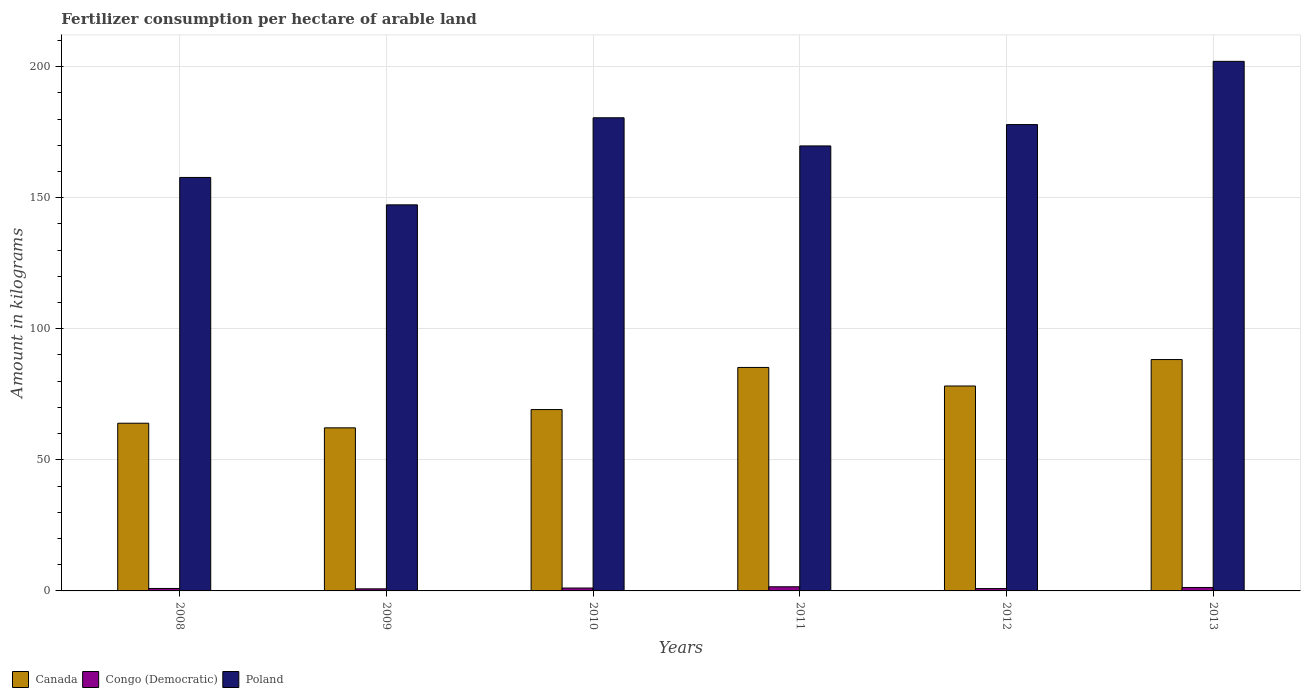Are the number of bars on each tick of the X-axis equal?
Offer a very short reply. Yes. How many bars are there on the 3rd tick from the left?
Ensure brevity in your answer.  3. How many bars are there on the 6th tick from the right?
Ensure brevity in your answer.  3. What is the amount of fertilizer consumption in Congo (Democratic) in 2012?
Give a very brief answer. 0.89. Across all years, what is the maximum amount of fertilizer consumption in Congo (Democratic)?
Provide a succinct answer. 1.58. Across all years, what is the minimum amount of fertilizer consumption in Canada?
Make the answer very short. 62.21. In which year was the amount of fertilizer consumption in Congo (Democratic) maximum?
Provide a short and direct response. 2011. In which year was the amount of fertilizer consumption in Canada minimum?
Provide a succinct answer. 2009. What is the total amount of fertilizer consumption in Poland in the graph?
Make the answer very short. 1035.09. What is the difference between the amount of fertilizer consumption in Canada in 2008 and that in 2009?
Offer a very short reply. 1.76. What is the difference between the amount of fertilizer consumption in Poland in 2010 and the amount of fertilizer consumption in Congo (Democratic) in 2009?
Provide a short and direct response. 179.68. What is the average amount of fertilizer consumption in Poland per year?
Your answer should be compact. 172.52. In the year 2009, what is the difference between the amount of fertilizer consumption in Canada and amount of fertilizer consumption in Poland?
Keep it short and to the point. -85.06. What is the ratio of the amount of fertilizer consumption in Poland in 2010 to that in 2012?
Keep it short and to the point. 1.01. Is the amount of fertilizer consumption in Congo (Democratic) in 2008 less than that in 2013?
Make the answer very short. Yes. Is the difference between the amount of fertilizer consumption in Canada in 2012 and 2013 greater than the difference between the amount of fertilizer consumption in Poland in 2012 and 2013?
Your answer should be very brief. Yes. What is the difference between the highest and the second highest amount of fertilizer consumption in Poland?
Offer a very short reply. 21.52. What is the difference between the highest and the lowest amount of fertilizer consumption in Canada?
Offer a terse response. 26.04. Is the sum of the amount of fertilizer consumption in Poland in 2009 and 2013 greater than the maximum amount of fertilizer consumption in Canada across all years?
Offer a very short reply. Yes. What does the 2nd bar from the left in 2013 represents?
Make the answer very short. Congo (Democratic). Are all the bars in the graph horizontal?
Your answer should be very brief. No. What is the difference between two consecutive major ticks on the Y-axis?
Give a very brief answer. 50. Are the values on the major ticks of Y-axis written in scientific E-notation?
Your response must be concise. No. Does the graph contain grids?
Offer a very short reply. Yes. How many legend labels are there?
Your answer should be very brief. 3. What is the title of the graph?
Your answer should be compact. Fertilizer consumption per hectare of arable land. What is the label or title of the X-axis?
Your response must be concise. Years. What is the label or title of the Y-axis?
Your answer should be compact. Amount in kilograms. What is the Amount in kilograms in Canada in 2008?
Ensure brevity in your answer.  63.96. What is the Amount in kilograms of Congo (Democratic) in 2008?
Offer a very short reply. 0.94. What is the Amount in kilograms in Poland in 2008?
Offer a terse response. 157.72. What is the Amount in kilograms of Canada in 2009?
Give a very brief answer. 62.21. What is the Amount in kilograms of Congo (Democratic) in 2009?
Give a very brief answer. 0.8. What is the Amount in kilograms of Poland in 2009?
Your answer should be compact. 147.27. What is the Amount in kilograms in Canada in 2010?
Keep it short and to the point. 69.18. What is the Amount in kilograms of Congo (Democratic) in 2010?
Your answer should be compact. 1.1. What is the Amount in kilograms of Poland in 2010?
Your answer should be very brief. 180.48. What is the Amount in kilograms in Canada in 2011?
Provide a short and direct response. 85.24. What is the Amount in kilograms of Congo (Democratic) in 2011?
Offer a terse response. 1.58. What is the Amount in kilograms of Poland in 2011?
Offer a terse response. 169.74. What is the Amount in kilograms in Canada in 2012?
Your answer should be very brief. 78.17. What is the Amount in kilograms in Congo (Democratic) in 2012?
Make the answer very short. 0.89. What is the Amount in kilograms in Poland in 2012?
Your response must be concise. 177.89. What is the Amount in kilograms of Canada in 2013?
Keep it short and to the point. 88.25. What is the Amount in kilograms in Congo (Democratic) in 2013?
Keep it short and to the point. 1.31. What is the Amount in kilograms in Poland in 2013?
Offer a terse response. 202. Across all years, what is the maximum Amount in kilograms in Canada?
Offer a terse response. 88.25. Across all years, what is the maximum Amount in kilograms in Congo (Democratic)?
Provide a succinct answer. 1.58. Across all years, what is the maximum Amount in kilograms of Poland?
Make the answer very short. 202. Across all years, what is the minimum Amount in kilograms of Canada?
Your response must be concise. 62.21. Across all years, what is the minimum Amount in kilograms in Congo (Democratic)?
Give a very brief answer. 0.8. Across all years, what is the minimum Amount in kilograms in Poland?
Offer a terse response. 147.27. What is the total Amount in kilograms of Canada in the graph?
Your answer should be compact. 447.01. What is the total Amount in kilograms of Congo (Democratic) in the graph?
Ensure brevity in your answer.  6.63. What is the total Amount in kilograms of Poland in the graph?
Offer a terse response. 1035.09. What is the difference between the Amount in kilograms of Canada in 2008 and that in 2009?
Your answer should be compact. 1.76. What is the difference between the Amount in kilograms of Congo (Democratic) in 2008 and that in 2009?
Your answer should be compact. 0.14. What is the difference between the Amount in kilograms in Poland in 2008 and that in 2009?
Provide a succinct answer. 10.45. What is the difference between the Amount in kilograms in Canada in 2008 and that in 2010?
Give a very brief answer. -5.21. What is the difference between the Amount in kilograms of Congo (Democratic) in 2008 and that in 2010?
Give a very brief answer. -0.16. What is the difference between the Amount in kilograms in Poland in 2008 and that in 2010?
Keep it short and to the point. -22.76. What is the difference between the Amount in kilograms in Canada in 2008 and that in 2011?
Offer a terse response. -21.28. What is the difference between the Amount in kilograms of Congo (Democratic) in 2008 and that in 2011?
Your response must be concise. -0.64. What is the difference between the Amount in kilograms in Poland in 2008 and that in 2011?
Give a very brief answer. -12.02. What is the difference between the Amount in kilograms of Canada in 2008 and that in 2012?
Your response must be concise. -14.2. What is the difference between the Amount in kilograms of Congo (Democratic) in 2008 and that in 2012?
Ensure brevity in your answer.  0.05. What is the difference between the Amount in kilograms of Poland in 2008 and that in 2012?
Provide a short and direct response. -20.17. What is the difference between the Amount in kilograms of Canada in 2008 and that in 2013?
Provide a short and direct response. -24.29. What is the difference between the Amount in kilograms of Congo (Democratic) in 2008 and that in 2013?
Provide a short and direct response. -0.37. What is the difference between the Amount in kilograms in Poland in 2008 and that in 2013?
Provide a short and direct response. -44.28. What is the difference between the Amount in kilograms in Canada in 2009 and that in 2010?
Offer a terse response. -6.97. What is the difference between the Amount in kilograms of Congo (Democratic) in 2009 and that in 2010?
Provide a short and direct response. -0.31. What is the difference between the Amount in kilograms of Poland in 2009 and that in 2010?
Offer a very short reply. -33.21. What is the difference between the Amount in kilograms in Canada in 2009 and that in 2011?
Offer a terse response. -23.03. What is the difference between the Amount in kilograms of Congo (Democratic) in 2009 and that in 2011?
Your answer should be very brief. -0.78. What is the difference between the Amount in kilograms of Poland in 2009 and that in 2011?
Offer a very short reply. -22.48. What is the difference between the Amount in kilograms in Canada in 2009 and that in 2012?
Provide a succinct answer. -15.96. What is the difference between the Amount in kilograms of Congo (Democratic) in 2009 and that in 2012?
Your response must be concise. -0.1. What is the difference between the Amount in kilograms in Poland in 2009 and that in 2012?
Your answer should be compact. -30.62. What is the difference between the Amount in kilograms of Canada in 2009 and that in 2013?
Offer a terse response. -26.04. What is the difference between the Amount in kilograms in Congo (Democratic) in 2009 and that in 2013?
Your answer should be very brief. -0.52. What is the difference between the Amount in kilograms in Poland in 2009 and that in 2013?
Ensure brevity in your answer.  -54.74. What is the difference between the Amount in kilograms of Canada in 2010 and that in 2011?
Keep it short and to the point. -16.07. What is the difference between the Amount in kilograms in Congo (Democratic) in 2010 and that in 2011?
Make the answer very short. -0.48. What is the difference between the Amount in kilograms of Poland in 2010 and that in 2011?
Make the answer very short. 10.74. What is the difference between the Amount in kilograms in Canada in 2010 and that in 2012?
Provide a short and direct response. -8.99. What is the difference between the Amount in kilograms in Congo (Democratic) in 2010 and that in 2012?
Your answer should be compact. 0.21. What is the difference between the Amount in kilograms in Poland in 2010 and that in 2012?
Ensure brevity in your answer.  2.59. What is the difference between the Amount in kilograms in Canada in 2010 and that in 2013?
Your answer should be compact. -19.08. What is the difference between the Amount in kilograms of Congo (Democratic) in 2010 and that in 2013?
Give a very brief answer. -0.21. What is the difference between the Amount in kilograms of Poland in 2010 and that in 2013?
Keep it short and to the point. -21.52. What is the difference between the Amount in kilograms of Canada in 2011 and that in 2012?
Your answer should be compact. 7.07. What is the difference between the Amount in kilograms of Congo (Democratic) in 2011 and that in 2012?
Offer a very short reply. 0.69. What is the difference between the Amount in kilograms of Poland in 2011 and that in 2012?
Your answer should be very brief. -8.14. What is the difference between the Amount in kilograms of Canada in 2011 and that in 2013?
Keep it short and to the point. -3.01. What is the difference between the Amount in kilograms of Congo (Democratic) in 2011 and that in 2013?
Your response must be concise. 0.27. What is the difference between the Amount in kilograms in Poland in 2011 and that in 2013?
Offer a terse response. -32.26. What is the difference between the Amount in kilograms of Canada in 2012 and that in 2013?
Provide a short and direct response. -10.08. What is the difference between the Amount in kilograms in Congo (Democratic) in 2012 and that in 2013?
Provide a succinct answer. -0.42. What is the difference between the Amount in kilograms of Poland in 2012 and that in 2013?
Give a very brief answer. -24.12. What is the difference between the Amount in kilograms of Canada in 2008 and the Amount in kilograms of Congo (Democratic) in 2009?
Provide a short and direct response. 63.17. What is the difference between the Amount in kilograms of Canada in 2008 and the Amount in kilograms of Poland in 2009?
Your response must be concise. -83.3. What is the difference between the Amount in kilograms in Congo (Democratic) in 2008 and the Amount in kilograms in Poland in 2009?
Your response must be concise. -146.32. What is the difference between the Amount in kilograms of Canada in 2008 and the Amount in kilograms of Congo (Democratic) in 2010?
Your response must be concise. 62.86. What is the difference between the Amount in kilograms of Canada in 2008 and the Amount in kilograms of Poland in 2010?
Your answer should be very brief. -116.51. What is the difference between the Amount in kilograms in Congo (Democratic) in 2008 and the Amount in kilograms in Poland in 2010?
Give a very brief answer. -179.54. What is the difference between the Amount in kilograms of Canada in 2008 and the Amount in kilograms of Congo (Democratic) in 2011?
Make the answer very short. 62.38. What is the difference between the Amount in kilograms in Canada in 2008 and the Amount in kilograms in Poland in 2011?
Keep it short and to the point. -105.78. What is the difference between the Amount in kilograms in Congo (Democratic) in 2008 and the Amount in kilograms in Poland in 2011?
Keep it short and to the point. -168.8. What is the difference between the Amount in kilograms in Canada in 2008 and the Amount in kilograms in Congo (Democratic) in 2012?
Offer a terse response. 63.07. What is the difference between the Amount in kilograms of Canada in 2008 and the Amount in kilograms of Poland in 2012?
Your response must be concise. -113.92. What is the difference between the Amount in kilograms of Congo (Democratic) in 2008 and the Amount in kilograms of Poland in 2012?
Ensure brevity in your answer.  -176.95. What is the difference between the Amount in kilograms in Canada in 2008 and the Amount in kilograms in Congo (Democratic) in 2013?
Your response must be concise. 62.65. What is the difference between the Amount in kilograms of Canada in 2008 and the Amount in kilograms of Poland in 2013?
Make the answer very short. -138.04. What is the difference between the Amount in kilograms in Congo (Democratic) in 2008 and the Amount in kilograms in Poland in 2013?
Keep it short and to the point. -201.06. What is the difference between the Amount in kilograms of Canada in 2009 and the Amount in kilograms of Congo (Democratic) in 2010?
Your answer should be compact. 61.1. What is the difference between the Amount in kilograms in Canada in 2009 and the Amount in kilograms in Poland in 2010?
Your answer should be very brief. -118.27. What is the difference between the Amount in kilograms of Congo (Democratic) in 2009 and the Amount in kilograms of Poland in 2010?
Keep it short and to the point. -179.68. What is the difference between the Amount in kilograms in Canada in 2009 and the Amount in kilograms in Congo (Democratic) in 2011?
Provide a short and direct response. 60.63. What is the difference between the Amount in kilograms of Canada in 2009 and the Amount in kilograms of Poland in 2011?
Your response must be concise. -107.53. What is the difference between the Amount in kilograms in Congo (Democratic) in 2009 and the Amount in kilograms in Poland in 2011?
Your response must be concise. -168.95. What is the difference between the Amount in kilograms in Canada in 2009 and the Amount in kilograms in Congo (Democratic) in 2012?
Give a very brief answer. 61.31. What is the difference between the Amount in kilograms in Canada in 2009 and the Amount in kilograms in Poland in 2012?
Provide a short and direct response. -115.68. What is the difference between the Amount in kilograms in Congo (Democratic) in 2009 and the Amount in kilograms in Poland in 2012?
Offer a very short reply. -177.09. What is the difference between the Amount in kilograms in Canada in 2009 and the Amount in kilograms in Congo (Democratic) in 2013?
Your answer should be very brief. 60.9. What is the difference between the Amount in kilograms in Canada in 2009 and the Amount in kilograms in Poland in 2013?
Provide a short and direct response. -139.79. What is the difference between the Amount in kilograms of Congo (Democratic) in 2009 and the Amount in kilograms of Poland in 2013?
Offer a terse response. -201.2. What is the difference between the Amount in kilograms of Canada in 2010 and the Amount in kilograms of Congo (Democratic) in 2011?
Offer a very short reply. 67.59. What is the difference between the Amount in kilograms in Canada in 2010 and the Amount in kilograms in Poland in 2011?
Give a very brief answer. -100.57. What is the difference between the Amount in kilograms in Congo (Democratic) in 2010 and the Amount in kilograms in Poland in 2011?
Provide a succinct answer. -168.64. What is the difference between the Amount in kilograms in Canada in 2010 and the Amount in kilograms in Congo (Democratic) in 2012?
Ensure brevity in your answer.  68.28. What is the difference between the Amount in kilograms in Canada in 2010 and the Amount in kilograms in Poland in 2012?
Offer a terse response. -108.71. What is the difference between the Amount in kilograms in Congo (Democratic) in 2010 and the Amount in kilograms in Poland in 2012?
Your response must be concise. -176.78. What is the difference between the Amount in kilograms in Canada in 2010 and the Amount in kilograms in Congo (Democratic) in 2013?
Keep it short and to the point. 67.86. What is the difference between the Amount in kilograms in Canada in 2010 and the Amount in kilograms in Poland in 2013?
Provide a short and direct response. -132.83. What is the difference between the Amount in kilograms in Congo (Democratic) in 2010 and the Amount in kilograms in Poland in 2013?
Keep it short and to the point. -200.9. What is the difference between the Amount in kilograms of Canada in 2011 and the Amount in kilograms of Congo (Democratic) in 2012?
Your answer should be very brief. 84.35. What is the difference between the Amount in kilograms of Canada in 2011 and the Amount in kilograms of Poland in 2012?
Offer a very short reply. -92.64. What is the difference between the Amount in kilograms in Congo (Democratic) in 2011 and the Amount in kilograms in Poland in 2012?
Keep it short and to the point. -176.3. What is the difference between the Amount in kilograms of Canada in 2011 and the Amount in kilograms of Congo (Democratic) in 2013?
Offer a very short reply. 83.93. What is the difference between the Amount in kilograms in Canada in 2011 and the Amount in kilograms in Poland in 2013?
Ensure brevity in your answer.  -116.76. What is the difference between the Amount in kilograms of Congo (Democratic) in 2011 and the Amount in kilograms of Poland in 2013?
Provide a short and direct response. -200.42. What is the difference between the Amount in kilograms in Canada in 2012 and the Amount in kilograms in Congo (Democratic) in 2013?
Offer a terse response. 76.86. What is the difference between the Amount in kilograms in Canada in 2012 and the Amount in kilograms in Poland in 2013?
Offer a very short reply. -123.83. What is the difference between the Amount in kilograms of Congo (Democratic) in 2012 and the Amount in kilograms of Poland in 2013?
Your response must be concise. -201.11. What is the average Amount in kilograms in Canada per year?
Keep it short and to the point. 74.5. What is the average Amount in kilograms of Congo (Democratic) per year?
Give a very brief answer. 1.11. What is the average Amount in kilograms of Poland per year?
Your answer should be compact. 172.52. In the year 2008, what is the difference between the Amount in kilograms of Canada and Amount in kilograms of Congo (Democratic)?
Make the answer very short. 63.02. In the year 2008, what is the difference between the Amount in kilograms in Canada and Amount in kilograms in Poland?
Offer a very short reply. -93.75. In the year 2008, what is the difference between the Amount in kilograms of Congo (Democratic) and Amount in kilograms of Poland?
Keep it short and to the point. -156.78. In the year 2009, what is the difference between the Amount in kilograms of Canada and Amount in kilograms of Congo (Democratic)?
Your answer should be compact. 61.41. In the year 2009, what is the difference between the Amount in kilograms of Canada and Amount in kilograms of Poland?
Your answer should be very brief. -85.06. In the year 2009, what is the difference between the Amount in kilograms in Congo (Democratic) and Amount in kilograms in Poland?
Provide a short and direct response. -146.47. In the year 2010, what is the difference between the Amount in kilograms of Canada and Amount in kilograms of Congo (Democratic)?
Ensure brevity in your answer.  68.07. In the year 2010, what is the difference between the Amount in kilograms of Canada and Amount in kilograms of Poland?
Provide a succinct answer. -111.3. In the year 2010, what is the difference between the Amount in kilograms of Congo (Democratic) and Amount in kilograms of Poland?
Give a very brief answer. -179.37. In the year 2011, what is the difference between the Amount in kilograms of Canada and Amount in kilograms of Congo (Democratic)?
Keep it short and to the point. 83.66. In the year 2011, what is the difference between the Amount in kilograms of Canada and Amount in kilograms of Poland?
Offer a very short reply. -84.5. In the year 2011, what is the difference between the Amount in kilograms of Congo (Democratic) and Amount in kilograms of Poland?
Make the answer very short. -168.16. In the year 2012, what is the difference between the Amount in kilograms of Canada and Amount in kilograms of Congo (Democratic)?
Make the answer very short. 77.27. In the year 2012, what is the difference between the Amount in kilograms of Canada and Amount in kilograms of Poland?
Ensure brevity in your answer.  -99.72. In the year 2012, what is the difference between the Amount in kilograms of Congo (Democratic) and Amount in kilograms of Poland?
Your answer should be very brief. -176.99. In the year 2013, what is the difference between the Amount in kilograms in Canada and Amount in kilograms in Congo (Democratic)?
Your answer should be compact. 86.94. In the year 2013, what is the difference between the Amount in kilograms of Canada and Amount in kilograms of Poland?
Provide a succinct answer. -113.75. In the year 2013, what is the difference between the Amount in kilograms in Congo (Democratic) and Amount in kilograms in Poland?
Provide a succinct answer. -200.69. What is the ratio of the Amount in kilograms of Canada in 2008 to that in 2009?
Your answer should be compact. 1.03. What is the ratio of the Amount in kilograms of Congo (Democratic) in 2008 to that in 2009?
Give a very brief answer. 1.18. What is the ratio of the Amount in kilograms of Poland in 2008 to that in 2009?
Your response must be concise. 1.07. What is the ratio of the Amount in kilograms of Canada in 2008 to that in 2010?
Your response must be concise. 0.92. What is the ratio of the Amount in kilograms in Congo (Democratic) in 2008 to that in 2010?
Your answer should be very brief. 0.85. What is the ratio of the Amount in kilograms of Poland in 2008 to that in 2010?
Your answer should be very brief. 0.87. What is the ratio of the Amount in kilograms in Canada in 2008 to that in 2011?
Provide a short and direct response. 0.75. What is the ratio of the Amount in kilograms of Congo (Democratic) in 2008 to that in 2011?
Your answer should be very brief. 0.59. What is the ratio of the Amount in kilograms in Poland in 2008 to that in 2011?
Your answer should be compact. 0.93. What is the ratio of the Amount in kilograms in Canada in 2008 to that in 2012?
Offer a terse response. 0.82. What is the ratio of the Amount in kilograms of Congo (Democratic) in 2008 to that in 2012?
Make the answer very short. 1.05. What is the ratio of the Amount in kilograms in Poland in 2008 to that in 2012?
Offer a very short reply. 0.89. What is the ratio of the Amount in kilograms of Canada in 2008 to that in 2013?
Offer a very short reply. 0.72. What is the ratio of the Amount in kilograms of Congo (Democratic) in 2008 to that in 2013?
Provide a succinct answer. 0.72. What is the ratio of the Amount in kilograms of Poland in 2008 to that in 2013?
Offer a terse response. 0.78. What is the ratio of the Amount in kilograms of Canada in 2009 to that in 2010?
Ensure brevity in your answer.  0.9. What is the ratio of the Amount in kilograms of Congo (Democratic) in 2009 to that in 2010?
Ensure brevity in your answer.  0.72. What is the ratio of the Amount in kilograms in Poland in 2009 to that in 2010?
Your response must be concise. 0.82. What is the ratio of the Amount in kilograms of Canada in 2009 to that in 2011?
Offer a very short reply. 0.73. What is the ratio of the Amount in kilograms in Congo (Democratic) in 2009 to that in 2011?
Keep it short and to the point. 0.5. What is the ratio of the Amount in kilograms in Poland in 2009 to that in 2011?
Give a very brief answer. 0.87. What is the ratio of the Amount in kilograms in Canada in 2009 to that in 2012?
Your answer should be very brief. 0.8. What is the ratio of the Amount in kilograms in Congo (Democratic) in 2009 to that in 2012?
Your answer should be compact. 0.89. What is the ratio of the Amount in kilograms of Poland in 2009 to that in 2012?
Provide a succinct answer. 0.83. What is the ratio of the Amount in kilograms of Canada in 2009 to that in 2013?
Offer a terse response. 0.7. What is the ratio of the Amount in kilograms in Congo (Democratic) in 2009 to that in 2013?
Make the answer very short. 0.61. What is the ratio of the Amount in kilograms in Poland in 2009 to that in 2013?
Ensure brevity in your answer.  0.73. What is the ratio of the Amount in kilograms of Canada in 2010 to that in 2011?
Provide a succinct answer. 0.81. What is the ratio of the Amount in kilograms in Congo (Democratic) in 2010 to that in 2011?
Your response must be concise. 0.7. What is the ratio of the Amount in kilograms of Poland in 2010 to that in 2011?
Ensure brevity in your answer.  1.06. What is the ratio of the Amount in kilograms of Canada in 2010 to that in 2012?
Your response must be concise. 0.89. What is the ratio of the Amount in kilograms of Congo (Democratic) in 2010 to that in 2012?
Offer a terse response. 1.23. What is the ratio of the Amount in kilograms of Poland in 2010 to that in 2012?
Your response must be concise. 1.01. What is the ratio of the Amount in kilograms of Canada in 2010 to that in 2013?
Give a very brief answer. 0.78. What is the ratio of the Amount in kilograms in Congo (Democratic) in 2010 to that in 2013?
Give a very brief answer. 0.84. What is the ratio of the Amount in kilograms in Poland in 2010 to that in 2013?
Give a very brief answer. 0.89. What is the ratio of the Amount in kilograms in Canada in 2011 to that in 2012?
Provide a short and direct response. 1.09. What is the ratio of the Amount in kilograms of Congo (Democratic) in 2011 to that in 2012?
Make the answer very short. 1.77. What is the ratio of the Amount in kilograms in Poland in 2011 to that in 2012?
Provide a succinct answer. 0.95. What is the ratio of the Amount in kilograms in Canada in 2011 to that in 2013?
Keep it short and to the point. 0.97. What is the ratio of the Amount in kilograms in Congo (Democratic) in 2011 to that in 2013?
Provide a short and direct response. 1.2. What is the ratio of the Amount in kilograms of Poland in 2011 to that in 2013?
Offer a very short reply. 0.84. What is the ratio of the Amount in kilograms in Canada in 2012 to that in 2013?
Provide a short and direct response. 0.89. What is the ratio of the Amount in kilograms in Congo (Democratic) in 2012 to that in 2013?
Your answer should be compact. 0.68. What is the ratio of the Amount in kilograms in Poland in 2012 to that in 2013?
Your answer should be compact. 0.88. What is the difference between the highest and the second highest Amount in kilograms of Canada?
Your answer should be compact. 3.01. What is the difference between the highest and the second highest Amount in kilograms of Congo (Democratic)?
Keep it short and to the point. 0.27. What is the difference between the highest and the second highest Amount in kilograms in Poland?
Ensure brevity in your answer.  21.52. What is the difference between the highest and the lowest Amount in kilograms of Canada?
Your response must be concise. 26.04. What is the difference between the highest and the lowest Amount in kilograms in Congo (Democratic)?
Offer a terse response. 0.78. What is the difference between the highest and the lowest Amount in kilograms of Poland?
Offer a very short reply. 54.74. 